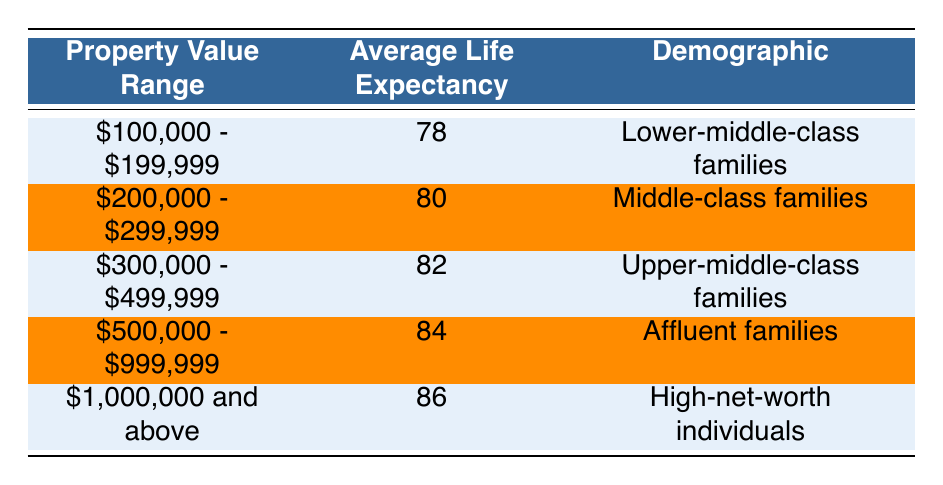What is the average life expectancy of homeowners in the property value range of $200,000 - $299,999? The average life expectancy for this property value range is specifically stated in the table, which shows that homeowners in this category have an average life expectancy of 80 years.
Answer: 80 Which demographic has the highest average life expectancy? By reviewing the table, it is clear that the demographic labeled "High-net-worth individuals," corresponding to properties valued at $1,000,000 and above, has the highest average life expectancy of 86 years.
Answer: High-net-worth individuals Is the average life expectancy of affluent families greater than that of upper-middle-class families? According to the table, affluent families have an average life expectancy of 84 years, while upper-middle-class families have an average of 82 years. Since 84 is greater than 82, the statement is true.
Answer: Yes What is the average life expectancy of lower-middle-class families compared to affluent families? Lower-middle-class families have an average life expectancy of 78 years, while affluent families have 84 years. The difference is calculated by subtracting 78 from 84, which results in 6 years. Thus, affluent families live 6 years longer on average.
Answer: 6 years Is the average life expectancy for homeowners in the $300,000 - $499,999 range higher than 80 years? The table indicates that the average life expectancy for this range is 82 years, which is indeed higher than 80. Therefore, the answer is true.
Answer: Yes What is the total average life expectancy for all demographics listed in the table? To find the total average life expectancy, we add the values: 78 + 80 + 82 + 84 + 86 = 410. Since there are 5 categories, we divide by 5 to find the average, giving us 410 / 5 = 82.
Answer: 82 What is the average life expectancy of homeowners in the property value range of $500,000 - $999,999? The table explicitly lists the average life expectancy for this property value range as 84 years.
Answer: 84 Which property value range has the lowest average life expectancy? Upon examining the table, the property value range of $100,000 - $199,999 has the lowest average life expectancy of 78 years among the listed demographics.
Answer: $100,000 - $199,999 